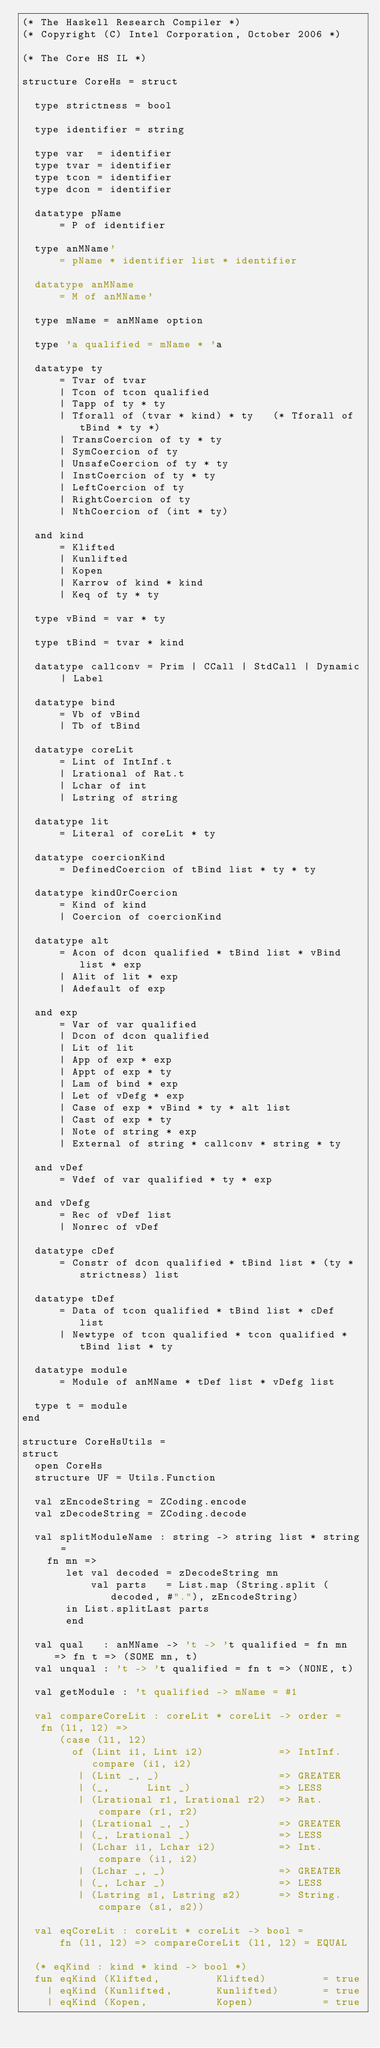Convert code to text. <code><loc_0><loc_0><loc_500><loc_500><_SML_>(* The Haskell Research Compiler *)
(* Copyright (C) Intel Corporation, October 2006 *)

(* The Core HS IL *)

structure CoreHs = struct

  type strictness = bool

  type identifier = string

  type var  = identifier
  type tvar = identifier
  type tcon = identifier
  type dcon = identifier

  datatype pName
      = P of identifier

  type anMName'
      = pName * identifier list * identifier

  datatype anMName
      = M of anMName'

  type mName = anMName option
  
  type 'a qualified = mName * 'a

  datatype ty
      = Tvar of tvar
      | Tcon of tcon qualified
      | Tapp of ty * ty
      | Tforall of (tvar * kind) * ty   (* Tforall of tBind * ty *)
      | TransCoercion of ty * ty
      | SymCoercion of ty
      | UnsafeCoercion of ty * ty
      | InstCoercion of ty * ty
      | LeftCoercion of ty
      | RightCoercion of ty
      | NthCoercion of (int * ty)

  and kind
      = Klifted
      | Kunlifted
      | Kopen
      | Karrow of kind * kind
      | Keq of ty * ty

  type vBind = var * ty

  type tBind = tvar * kind

  datatype callconv = Prim | CCall | StdCall | Dynamic | Label

  datatype bind
      = Vb of vBind
      | Tb of tBind

  datatype coreLit
      = Lint of IntInf.t
      | Lrational of Rat.t
      | Lchar of int
      | Lstring of string

  datatype lit
      = Literal of coreLit * ty

  datatype coercionKind
      = DefinedCoercion of tBind list * ty * ty

  datatype kindOrCoercion
      = Kind of kind
      | Coercion of coercionKind

  datatype alt
      = Acon of dcon qualified * tBind list * vBind list * exp
      | Alit of lit * exp
      | Adefault of exp

  and exp
      = Var of var qualified
      | Dcon of dcon qualified
      | Lit of lit
      | App of exp * exp
      | Appt of exp * ty
      | Lam of bind * exp
      | Let of vDefg * exp
      | Case of exp * vBind * ty * alt list 
      | Cast of exp * ty
      | Note of string * exp
      | External of string * callconv * string * ty

  and vDef
      = Vdef of var qualified * ty * exp

  and vDefg
      = Rec of vDef list
      | Nonrec of vDef

  datatype cDef
      = Constr of dcon qualified * tBind list * (ty * strictness) list

  datatype tDef
      = Data of tcon qualified * tBind list * cDef list
      | Newtype of tcon qualified * tcon qualified * tBind list * ty

  datatype module
      = Module of anMName * tDef list * vDefg list

  type t = module
end

structure CoreHsUtils =
struct
  open CoreHs
  structure UF = Utils.Function

  val zEncodeString = ZCoding.encode
  val zDecodeString = ZCoding.decode

  val splitModuleName : string -> string list * string =
    fn mn =>
       let val decoded = zDecodeString mn
           val parts   = List.map (String.split (decoded, #"."), zEncodeString)
       in List.splitLast parts
       end

  val qual   : anMName -> 't -> 't qualified = fn mn => fn t => (SOME mn, t)
  val unqual : 't -> 't qualified = fn t => (NONE, t)

  val getModule : 't qualified -> mName = #1

  val compareCoreLit : coreLit * coreLit -> order = 
   fn (l1, l2) => 
      (case (l1, l2)
        of (Lint i1, Lint i2)            => IntInf.compare (i1, i2)
         | (Lint _, _)                   => GREATER
         | (_,      Lint _)              => LESS
         | (Lrational r1, Lrational r2)  => Rat.compare (r1, r2)
         | (Lrational _, _)              => GREATER
         | (_, Lrational _)              => LESS
         | (Lchar i1, Lchar i2)          => Int.compare (i1, i2)
         | (Lchar _, _)                  => GREATER
         | (_, Lchar _)                  => LESS
         | (Lstring s1, Lstring s2)      => String.compare (s1, s2))

  val eqCoreLit : coreLit * coreLit -> bool = 
      fn (l1, l2) => compareCoreLit (l1, l2) = EQUAL

  (* eqKind : kind * kind -> bool *)
  fun eqKind (Klifted,         Klifted)         = true
    | eqKind (Kunlifted,       Kunlifted)       = true
    | eqKind (Kopen,           Kopen)           = true</code> 